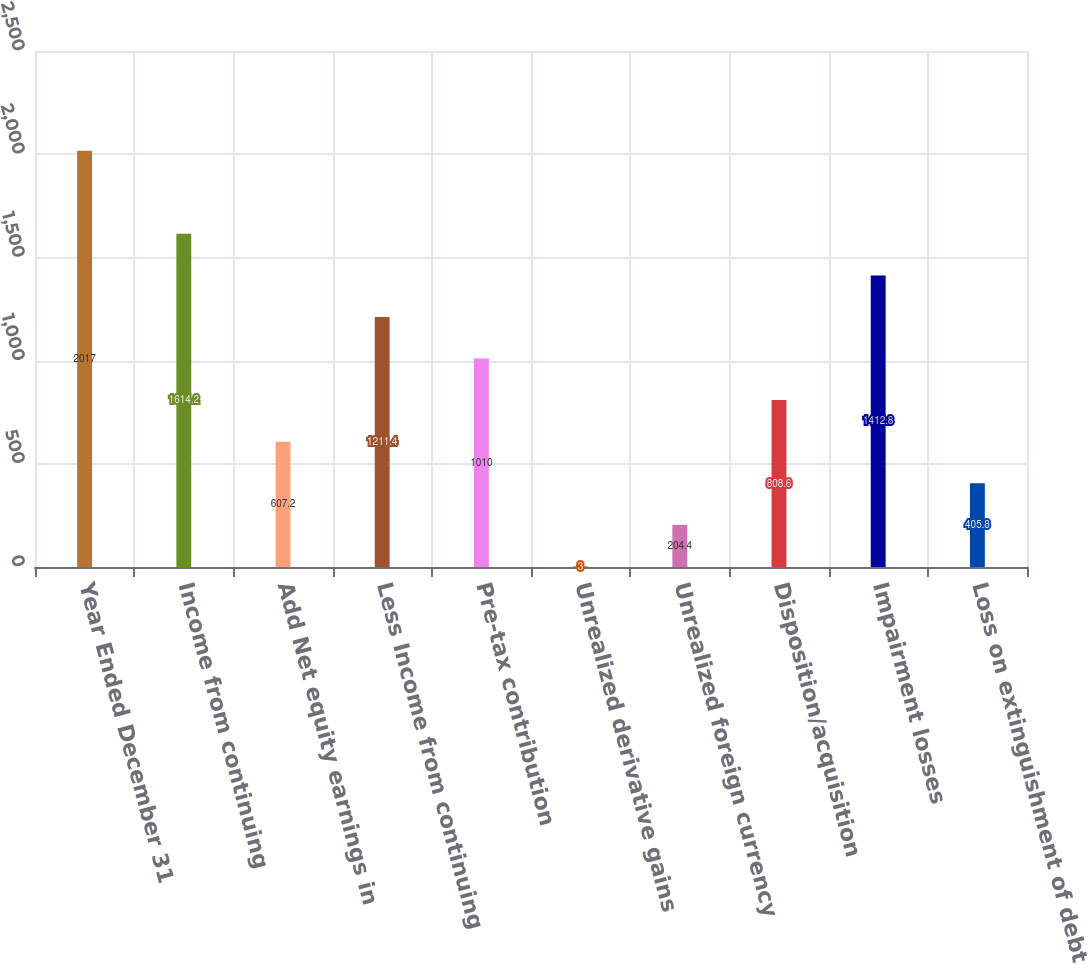Convert chart. <chart><loc_0><loc_0><loc_500><loc_500><bar_chart><fcel>Year Ended December 31<fcel>Income from continuing<fcel>Add Net equity earnings in<fcel>Less Income from continuing<fcel>Pre-tax contribution<fcel>Unrealized derivative gains<fcel>Unrealized foreign currency<fcel>Disposition/acquisition<fcel>Impairment losses<fcel>Loss on extinguishment of debt<nl><fcel>2017<fcel>1614.2<fcel>607.2<fcel>1211.4<fcel>1010<fcel>3<fcel>204.4<fcel>808.6<fcel>1412.8<fcel>405.8<nl></chart> 